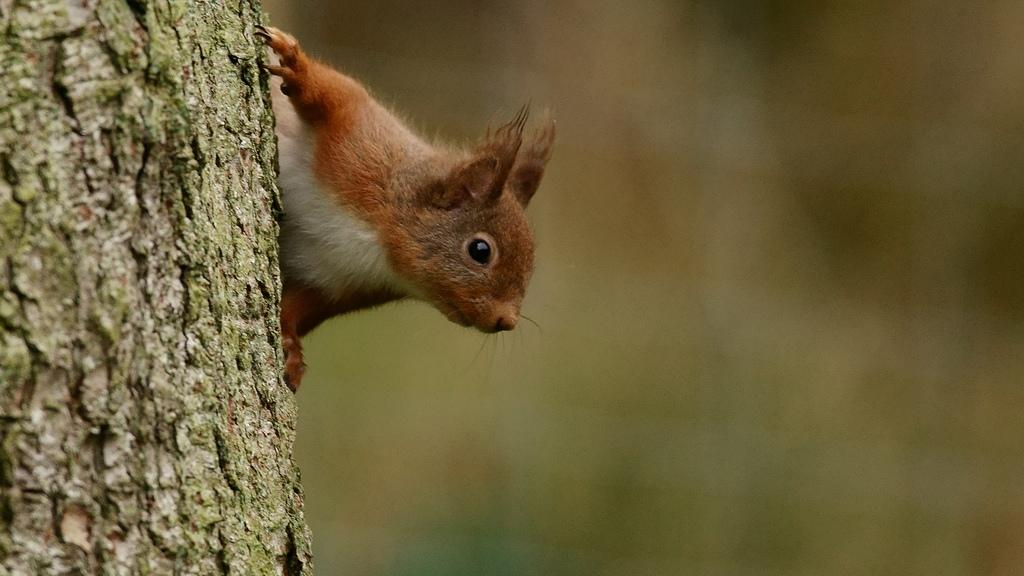What animal can be seen in the image? There is a squirrel in the image. Where is the squirrel located? The squirrel is present on a tree. What type of chin can be seen on the squirrel in the image? There is no chin visible on the squirrel in the image, as it is a squirrel and not a human. 